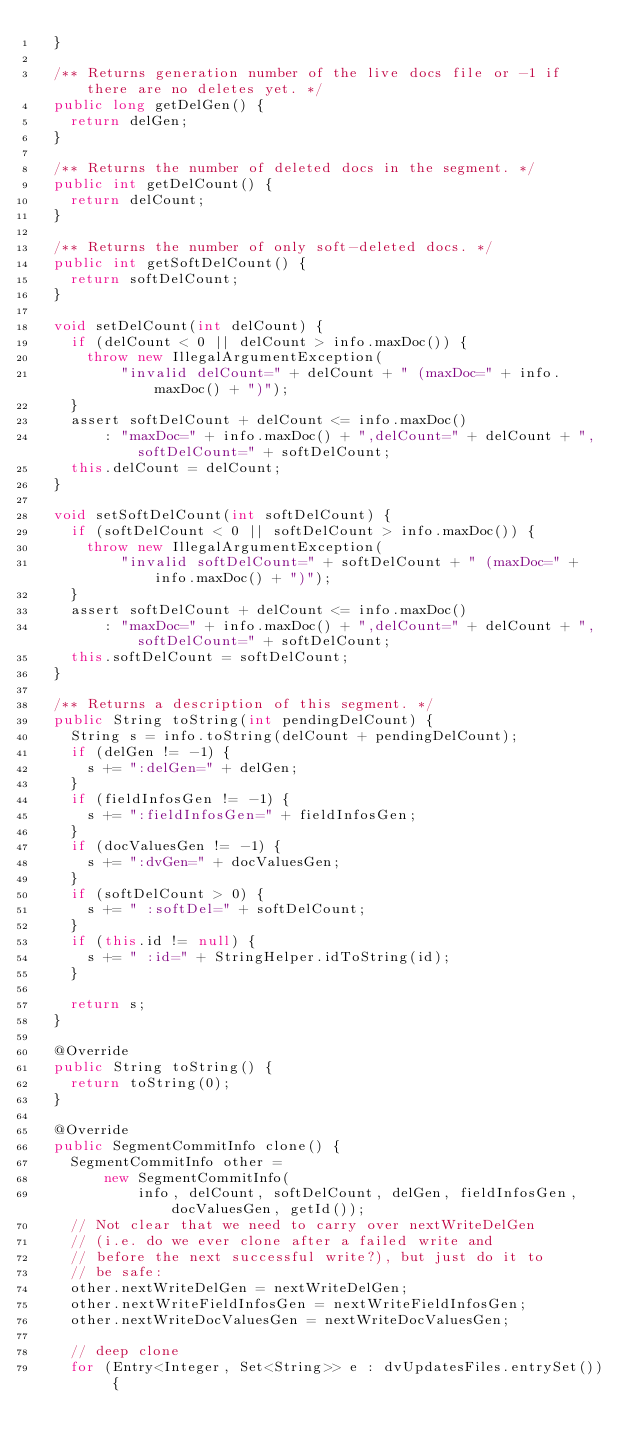<code> <loc_0><loc_0><loc_500><loc_500><_Java_>  }

  /** Returns generation number of the live docs file or -1 if there are no deletes yet. */
  public long getDelGen() {
    return delGen;
  }

  /** Returns the number of deleted docs in the segment. */
  public int getDelCount() {
    return delCount;
  }

  /** Returns the number of only soft-deleted docs. */
  public int getSoftDelCount() {
    return softDelCount;
  }

  void setDelCount(int delCount) {
    if (delCount < 0 || delCount > info.maxDoc()) {
      throw new IllegalArgumentException(
          "invalid delCount=" + delCount + " (maxDoc=" + info.maxDoc() + ")");
    }
    assert softDelCount + delCount <= info.maxDoc()
        : "maxDoc=" + info.maxDoc() + ",delCount=" + delCount + ",softDelCount=" + softDelCount;
    this.delCount = delCount;
  }

  void setSoftDelCount(int softDelCount) {
    if (softDelCount < 0 || softDelCount > info.maxDoc()) {
      throw new IllegalArgumentException(
          "invalid softDelCount=" + softDelCount + " (maxDoc=" + info.maxDoc() + ")");
    }
    assert softDelCount + delCount <= info.maxDoc()
        : "maxDoc=" + info.maxDoc() + ",delCount=" + delCount + ",softDelCount=" + softDelCount;
    this.softDelCount = softDelCount;
  }

  /** Returns a description of this segment. */
  public String toString(int pendingDelCount) {
    String s = info.toString(delCount + pendingDelCount);
    if (delGen != -1) {
      s += ":delGen=" + delGen;
    }
    if (fieldInfosGen != -1) {
      s += ":fieldInfosGen=" + fieldInfosGen;
    }
    if (docValuesGen != -1) {
      s += ":dvGen=" + docValuesGen;
    }
    if (softDelCount > 0) {
      s += " :softDel=" + softDelCount;
    }
    if (this.id != null) {
      s += " :id=" + StringHelper.idToString(id);
    }

    return s;
  }

  @Override
  public String toString() {
    return toString(0);
  }

  @Override
  public SegmentCommitInfo clone() {
    SegmentCommitInfo other =
        new SegmentCommitInfo(
            info, delCount, softDelCount, delGen, fieldInfosGen, docValuesGen, getId());
    // Not clear that we need to carry over nextWriteDelGen
    // (i.e. do we ever clone after a failed write and
    // before the next successful write?), but just do it to
    // be safe:
    other.nextWriteDelGen = nextWriteDelGen;
    other.nextWriteFieldInfosGen = nextWriteFieldInfosGen;
    other.nextWriteDocValuesGen = nextWriteDocValuesGen;

    // deep clone
    for (Entry<Integer, Set<String>> e : dvUpdatesFiles.entrySet()) {</code> 